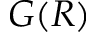Convert formula to latex. <formula><loc_0><loc_0><loc_500><loc_500>G ( R )</formula> 